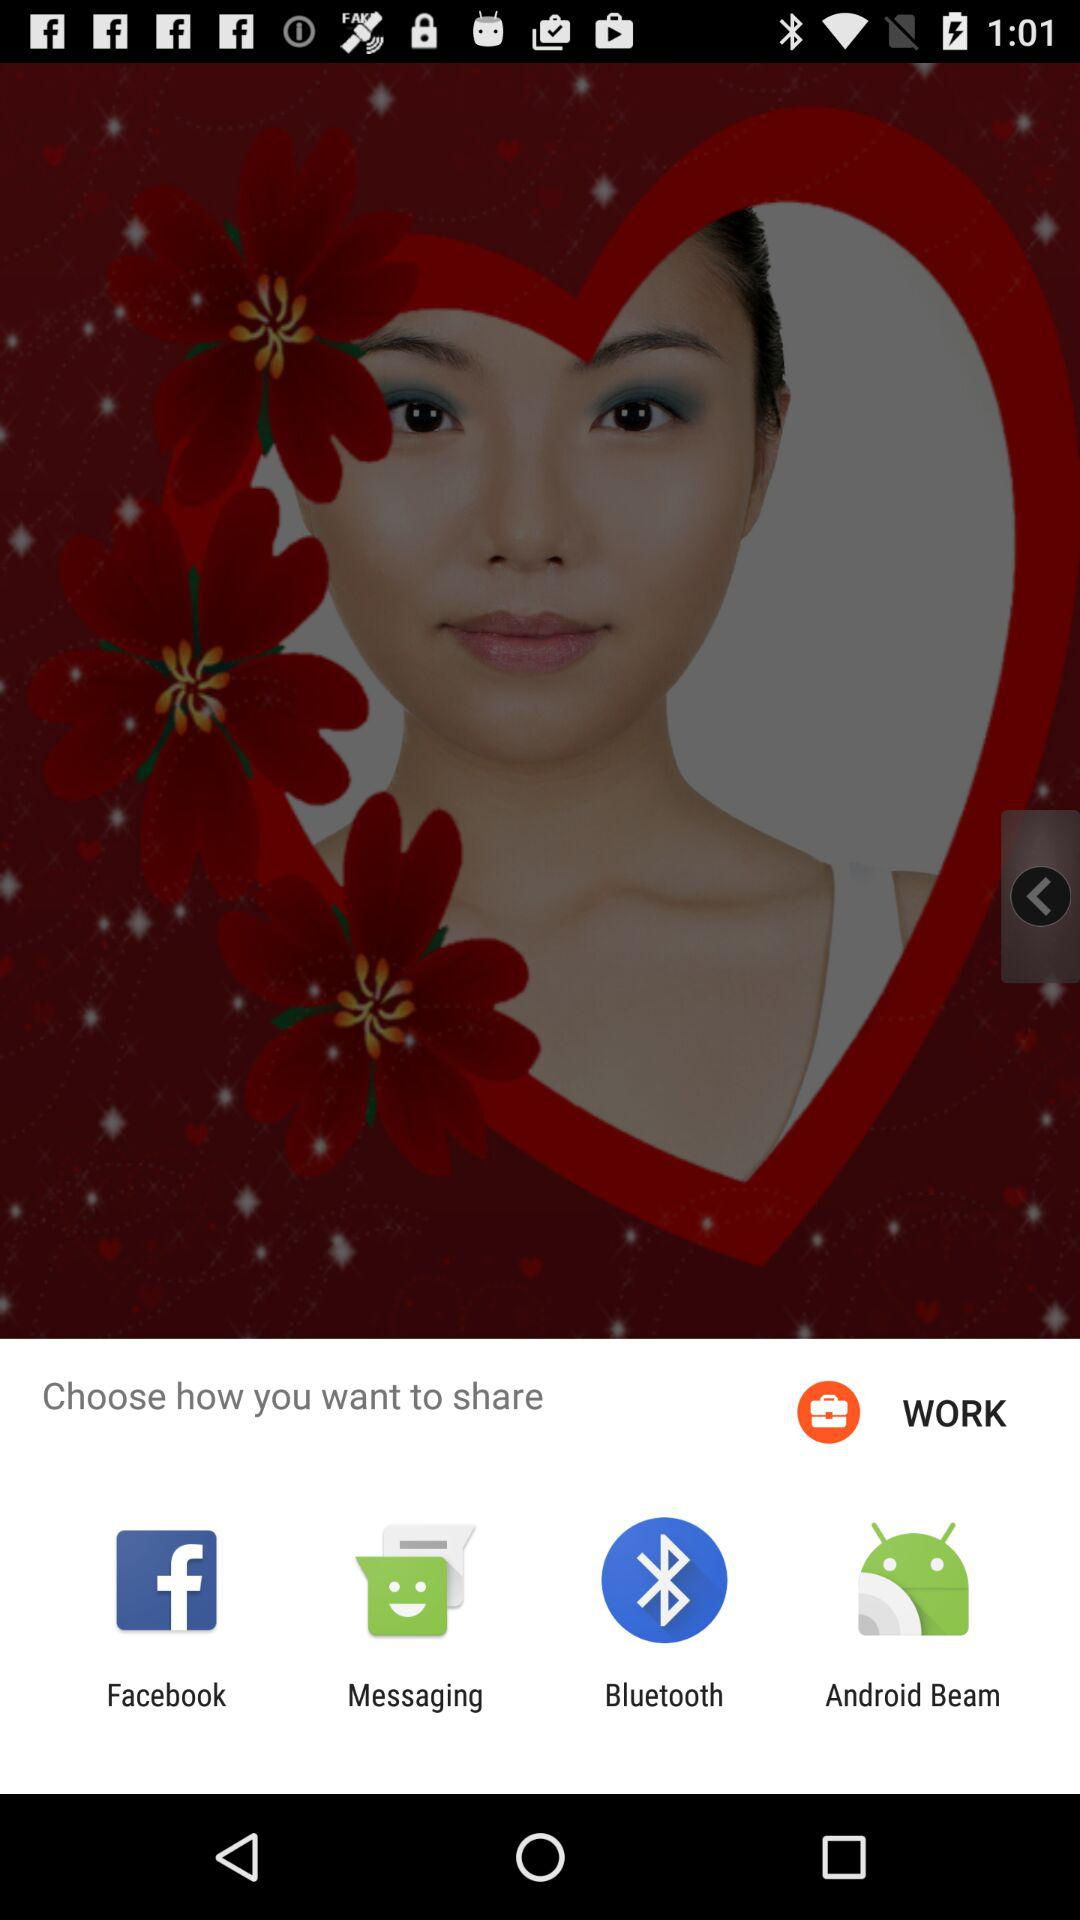What are the options for sharing the content? The options are "Facebook", "Messaging", "Bluetooth" and "Android Beam". 